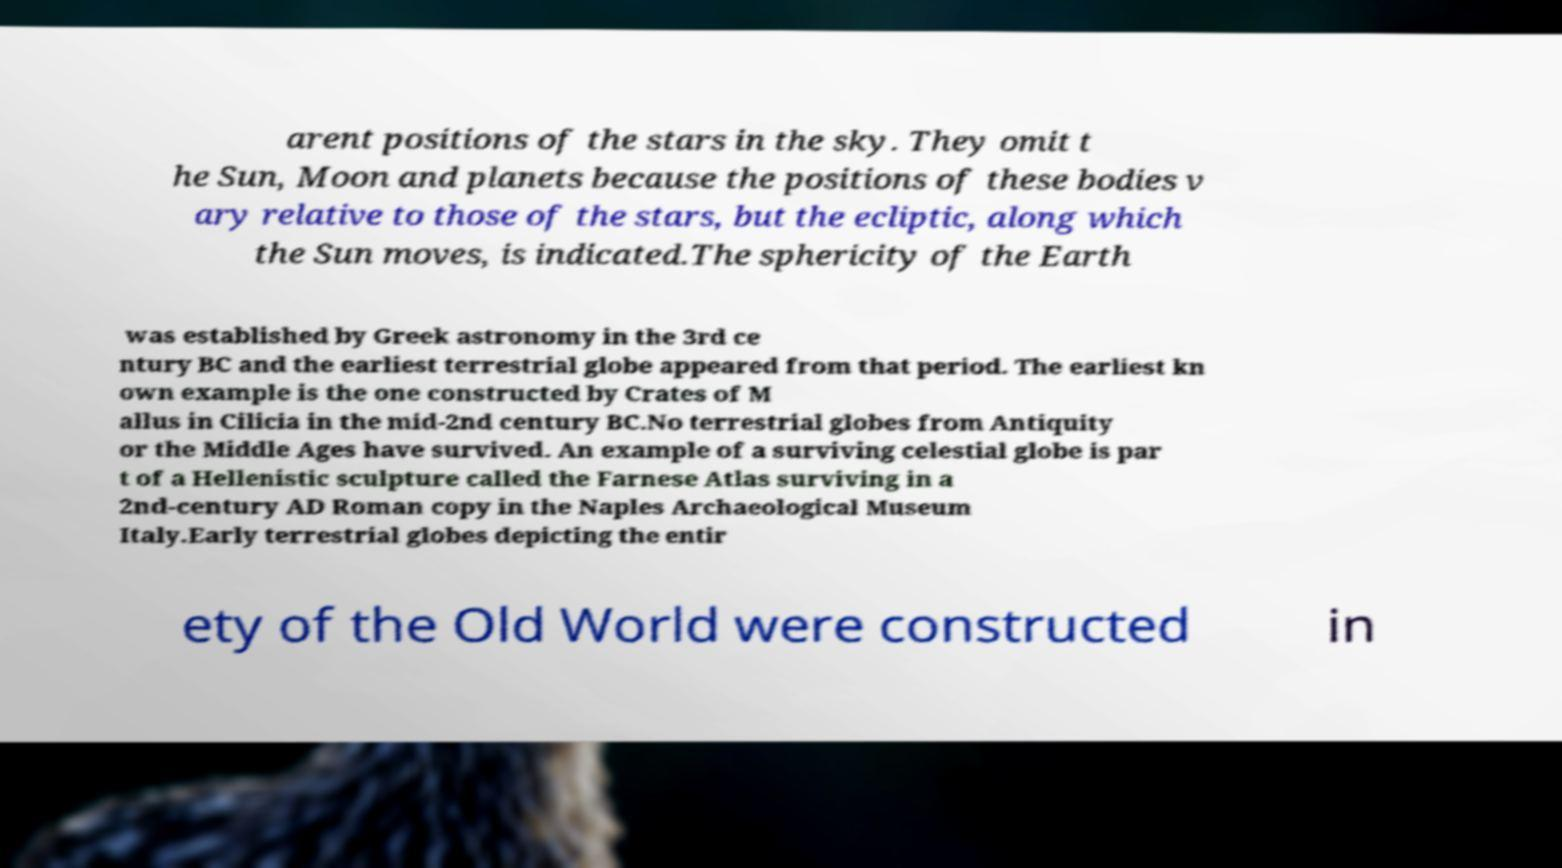Can you read and provide the text displayed in the image?This photo seems to have some interesting text. Can you extract and type it out for me? arent positions of the stars in the sky. They omit t he Sun, Moon and planets because the positions of these bodies v ary relative to those of the stars, but the ecliptic, along which the Sun moves, is indicated.The sphericity of the Earth was established by Greek astronomy in the 3rd ce ntury BC and the earliest terrestrial globe appeared from that period. The earliest kn own example is the one constructed by Crates of M allus in Cilicia in the mid-2nd century BC.No terrestrial globes from Antiquity or the Middle Ages have survived. An example of a surviving celestial globe is par t of a Hellenistic sculpture called the Farnese Atlas surviving in a 2nd-century AD Roman copy in the Naples Archaeological Museum Italy.Early terrestrial globes depicting the entir ety of the Old World were constructed in 